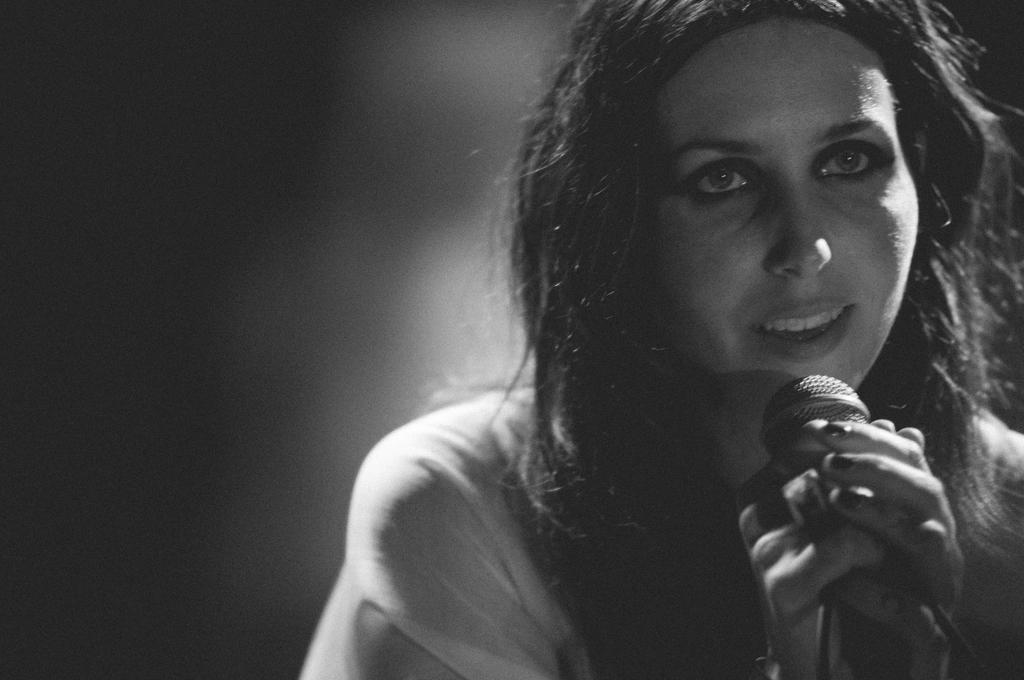Who is the main subject in the image? There is a woman in the image. What is the woman holding in her hand? The woman is holding a mic in her hand. What is the woman doing in the image? The woman is singing. How many cakes can be seen on the stage while the woman is singing? There are no cakes visible in the image; it only shows the woman holding a mic and singing. 